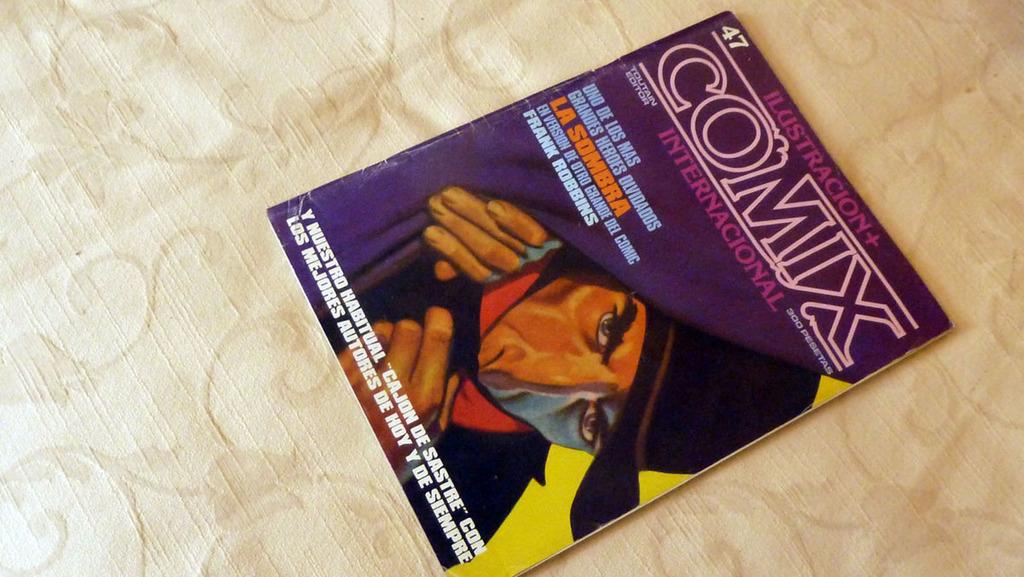<image>
Render a clear and concise summary of the photo. A magazine titled Comix with a picture of a man in a black hat on it. 